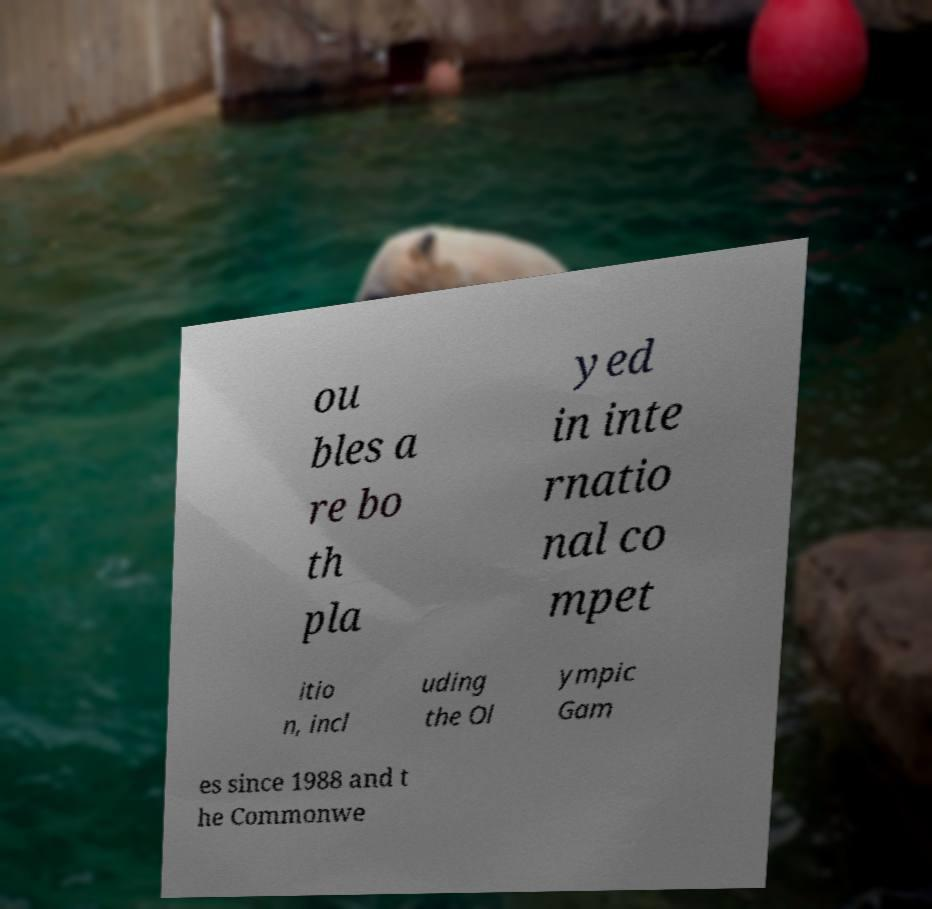Please identify and transcribe the text found in this image. ou bles a re bo th pla yed in inte rnatio nal co mpet itio n, incl uding the Ol ympic Gam es since 1988 and t he Commonwe 